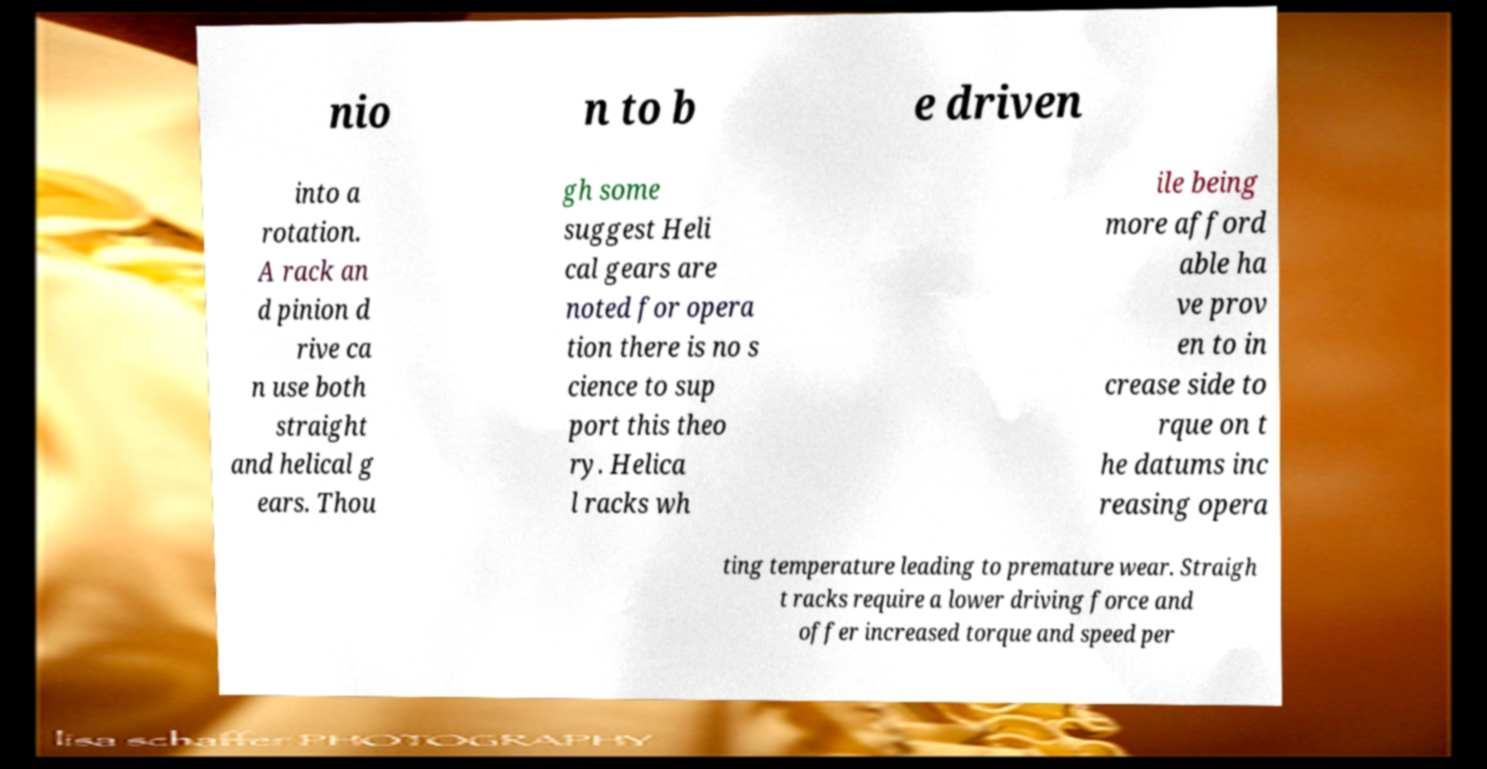Can you read and provide the text displayed in the image?This photo seems to have some interesting text. Can you extract and type it out for me? nio n to b e driven into a rotation. A rack an d pinion d rive ca n use both straight and helical g ears. Thou gh some suggest Heli cal gears are noted for opera tion there is no s cience to sup port this theo ry. Helica l racks wh ile being more afford able ha ve prov en to in crease side to rque on t he datums inc reasing opera ting temperature leading to premature wear. Straigh t racks require a lower driving force and offer increased torque and speed per 